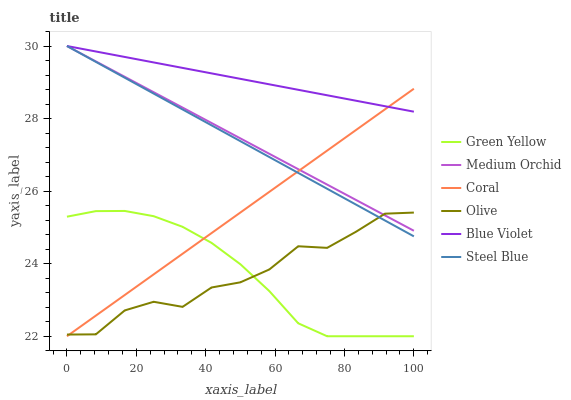Does Olive have the minimum area under the curve?
Answer yes or no. Yes. Does Blue Violet have the maximum area under the curve?
Answer yes or no. Yes. Does Medium Orchid have the minimum area under the curve?
Answer yes or no. No. Does Medium Orchid have the maximum area under the curve?
Answer yes or no. No. Is Blue Violet the smoothest?
Answer yes or no. Yes. Is Olive the roughest?
Answer yes or no. Yes. Is Medium Orchid the smoothest?
Answer yes or no. No. Is Medium Orchid the roughest?
Answer yes or no. No. Does Coral have the lowest value?
Answer yes or no. Yes. Does Medium Orchid have the lowest value?
Answer yes or no. No. Does Blue Violet have the highest value?
Answer yes or no. Yes. Does Olive have the highest value?
Answer yes or no. No. Is Green Yellow less than Steel Blue?
Answer yes or no. Yes. Is Medium Orchid greater than Green Yellow?
Answer yes or no. Yes. Does Coral intersect Green Yellow?
Answer yes or no. Yes. Is Coral less than Green Yellow?
Answer yes or no. No. Is Coral greater than Green Yellow?
Answer yes or no. No. Does Green Yellow intersect Steel Blue?
Answer yes or no. No. 